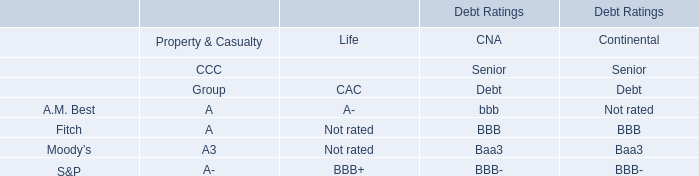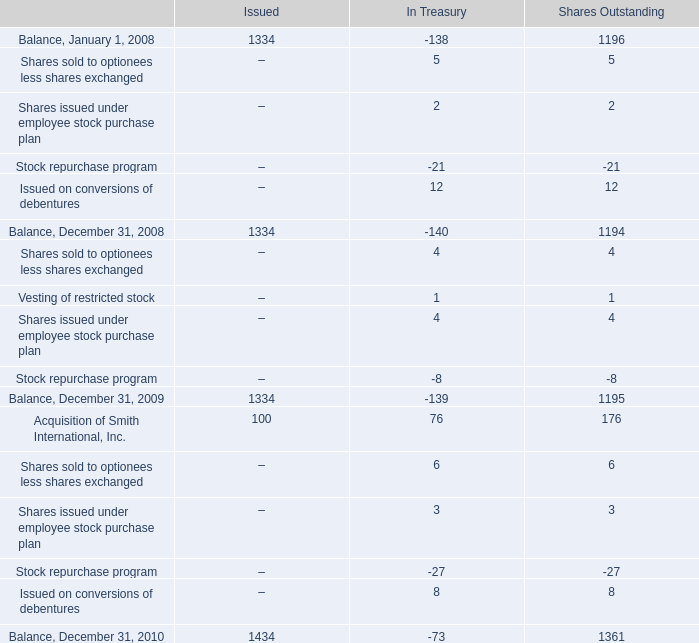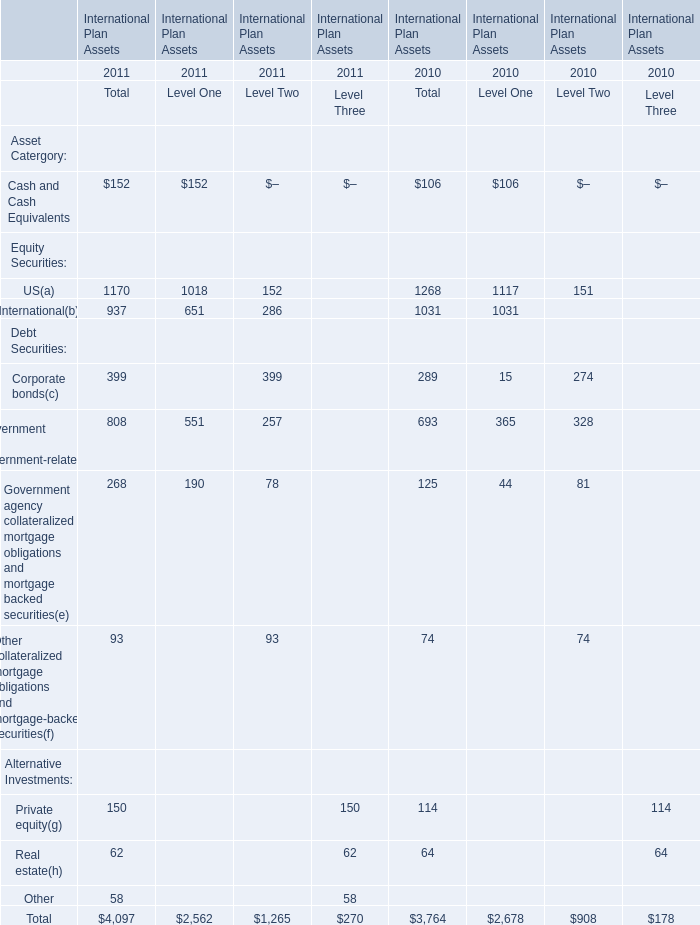How much of Level One is there in total in 2011 without Cash and Cash Equivalents and US? 
Computations: ((651 + 551) + 190)
Answer: 1392.0. 